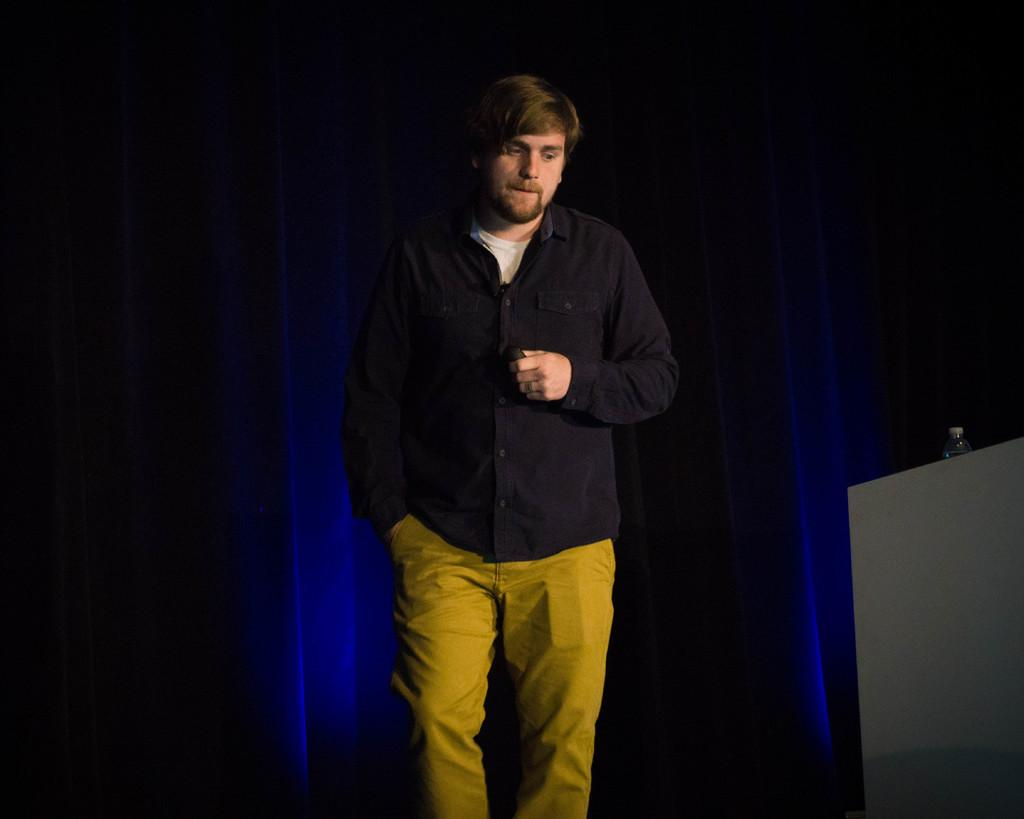What object can be seen in the image? There is a bottle in the image. Who is present in the image? There is a man standing in the image. What can be observed about the background of the image? The background of the image is dark. What type of skirt is the man wearing in the image? The man is not wearing a skirt in the image; he is wearing clothing appropriate for a man. What type of pan can be seen in the image? There is no pan present in the image; it only features a bottle and a man. 